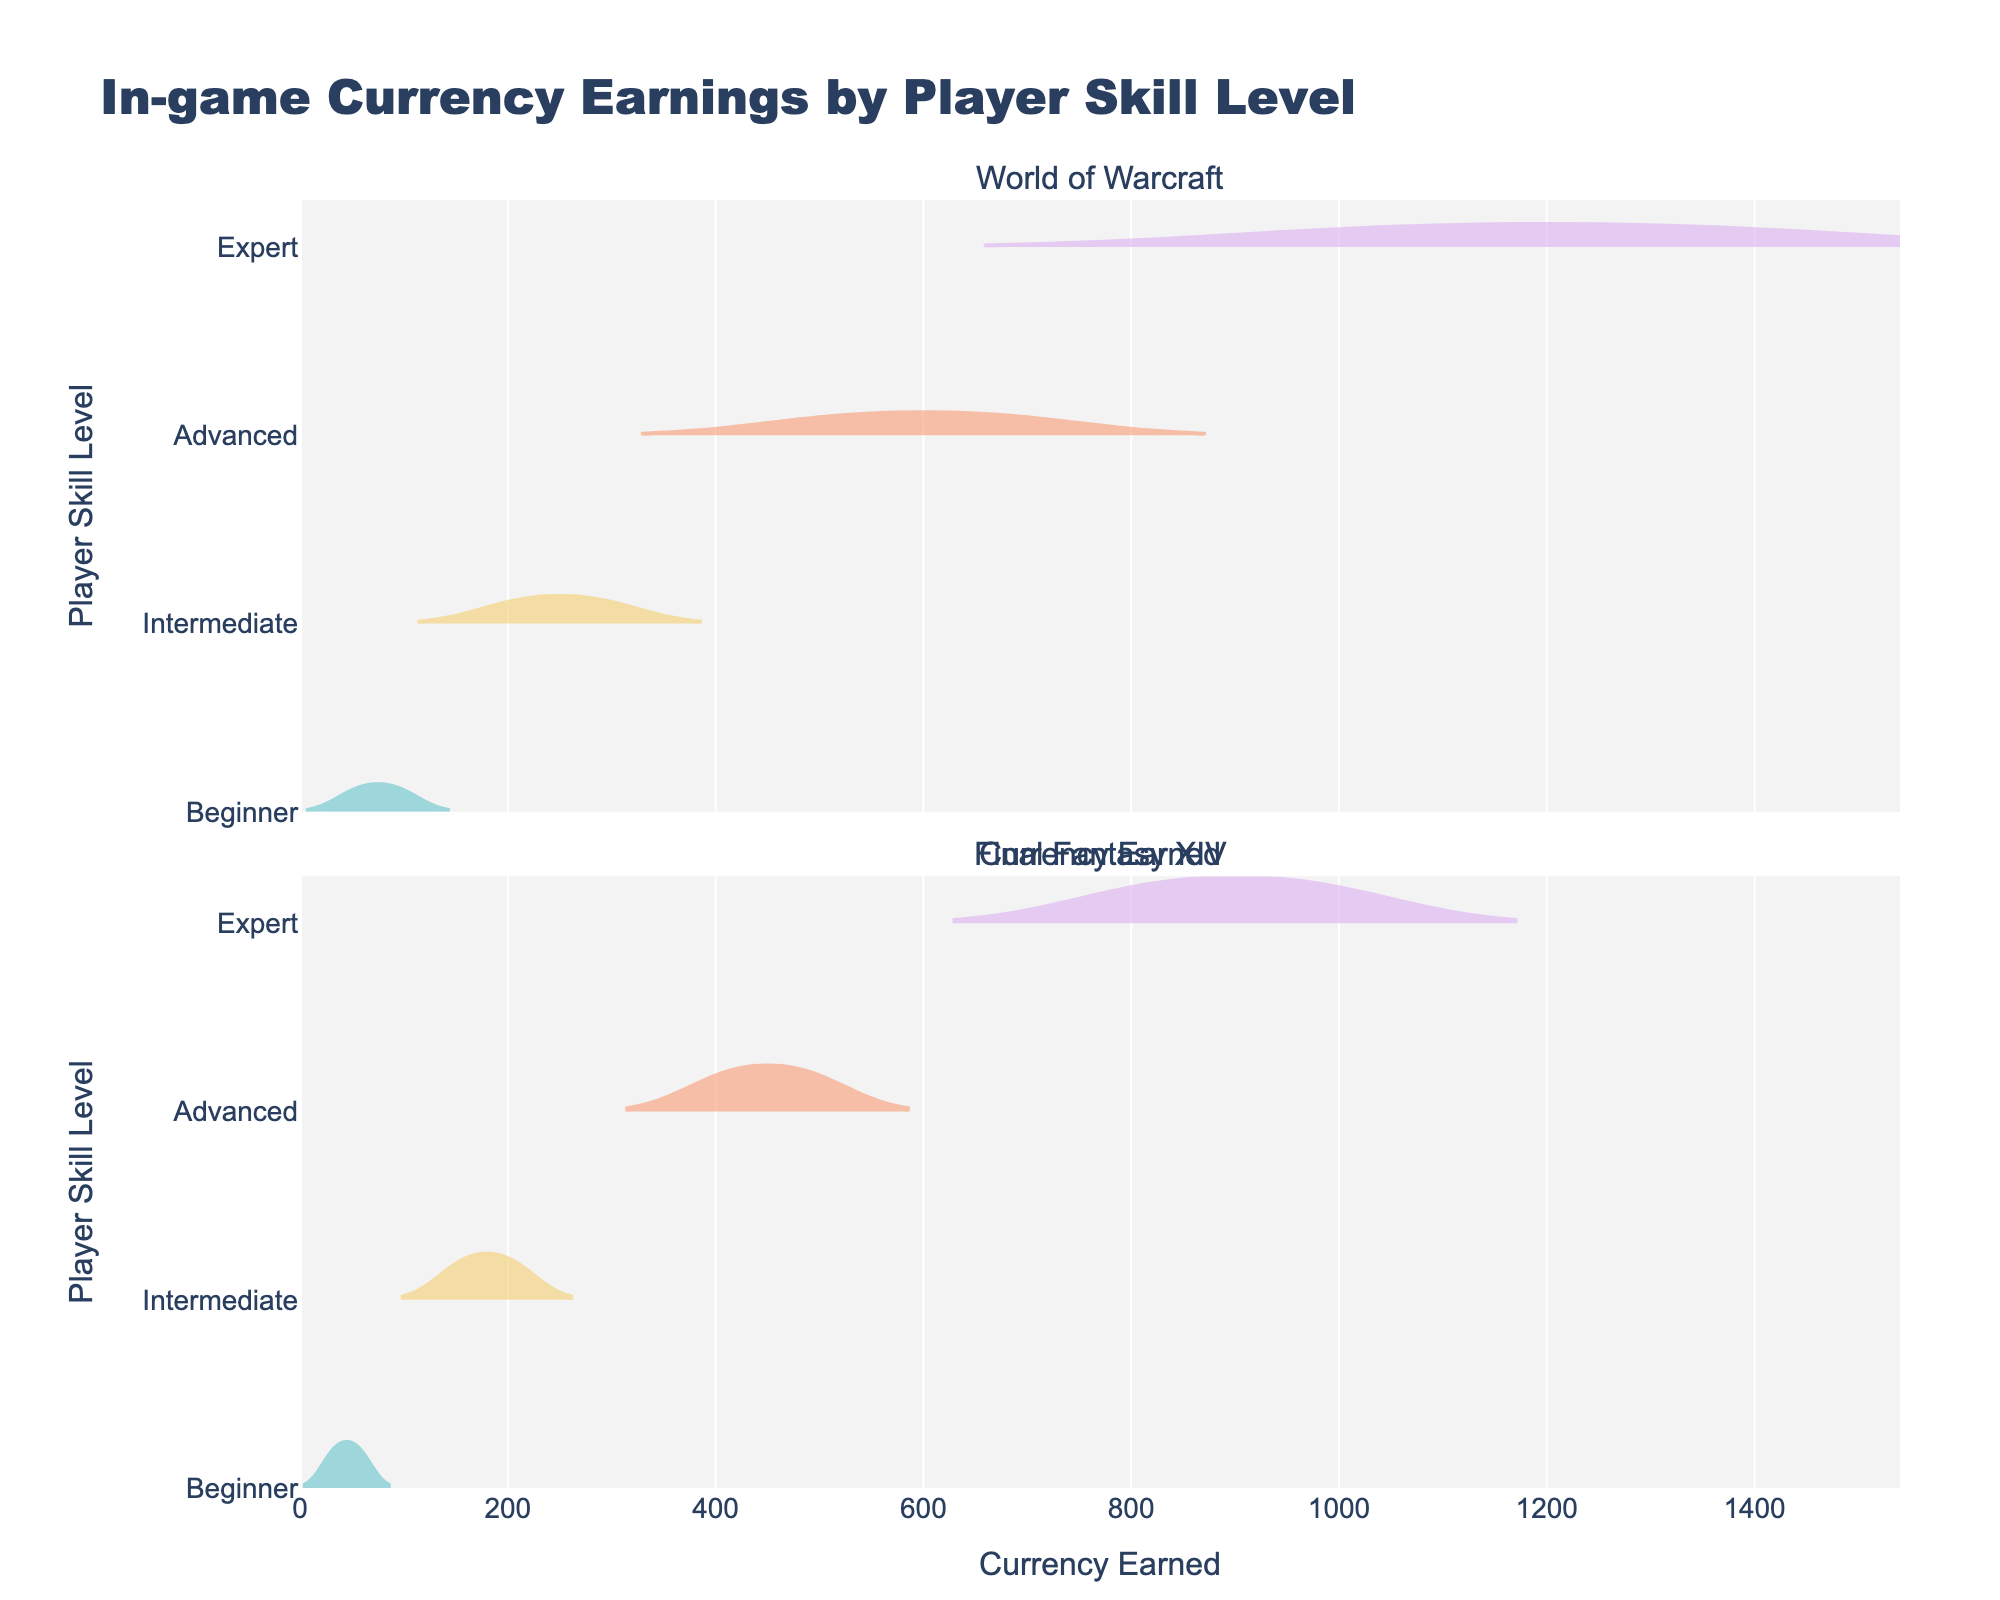what is the title of the figure? The text at the top-middle of the figure reads 'In-game Currency Earnings by Player Skill Level.'
Answer: In-game Currency Earnings by Player Skill Level what does the x-axis represent? The label for the x-axis on the bottom of the figure indicates that it shows the amount of 'Currency Earned.'
Answer: Currency Earned what does the y-axis represent? The label for the y-axis on the left side of the figure indicates it shows 'Player Skill Level.'
Answer: Player Skill Level Which skill level has the highest average earnings in World of Warcraft? The violin plots for World of Warcraft show the meanline of each skill level's earnings. The 'Expert' skill level has a meanline at the highest value.
Answer: Expert How does the currency earned by Intermediate players in Final Fantasy XIV compare to Advanced players in World of Warcraft? The meanline for 'Intermediate' players in Final Fantasy XIV is around 180 while for 'Advanced' players in World of Warcraft it's around 600.
Answer: Advanced players in World of Warcraft earn more What can you infer by comparing the spread of currency earnings between Beginners and Experts in Final Fantasy XIV? The violin plots for 'Beginner' and 'Expert' players in Final Fantasy XIV show that Beginners have a narrower spread (30-60), while Experts have a wider spread (800-1000). This indicates higher variability in earnings for Expert players.
Answer: Experts have a wider spread and higher variability For which game do Intermediate players earn more, World of Warcraft or Final Fantasy XIV? Comparing the meanlines in the violin plots for Intermediate players, World of Warcraft has higher average earnings around 250 compared to Final Fantasy XIV which is around 180.
Answer: World of Warcraft What is the range of currency earnings for Advanced players in Final Fantasy XIV? The violin plot for 'Advanced' players in Final Fantasy XIV shows the spread of data points. The range is from 400 to 500.
Answer: 400 to 500 In which game do Expert players have higher earnings on average? The meanline of the 'Expert' skill level in World of Warcraft is higher compared to Final Fantasy XIV.
Answer: World of Warcraft What is the median earnings of Beginner players in World of Warcraft? The median is indicated by the box inside the violin plot. In World of Warcraft, the median for Beginners is around 75.
Answer: 75 